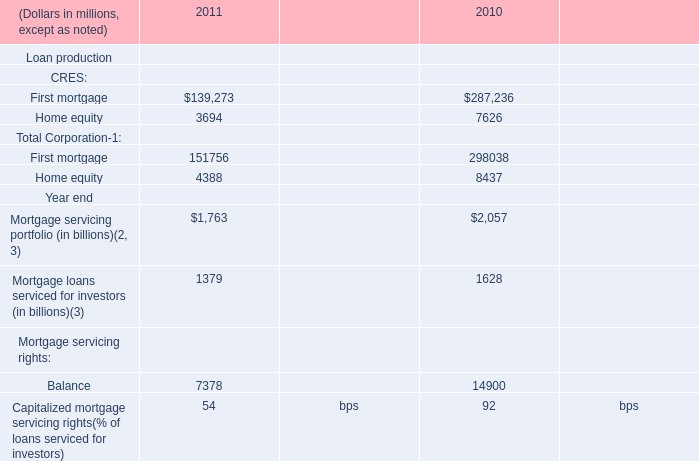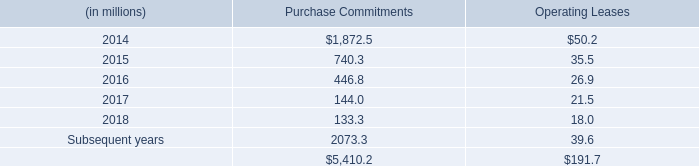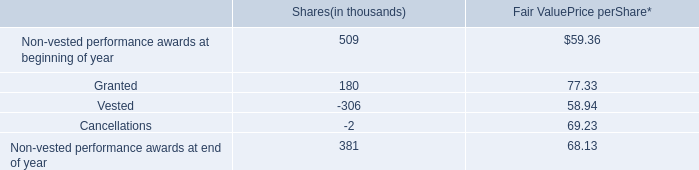What's the difference of First mortgage of CRES between 2011 and 2010? (in millions) 
Computations: (139273 - 287236)
Answer: -147963.0. 